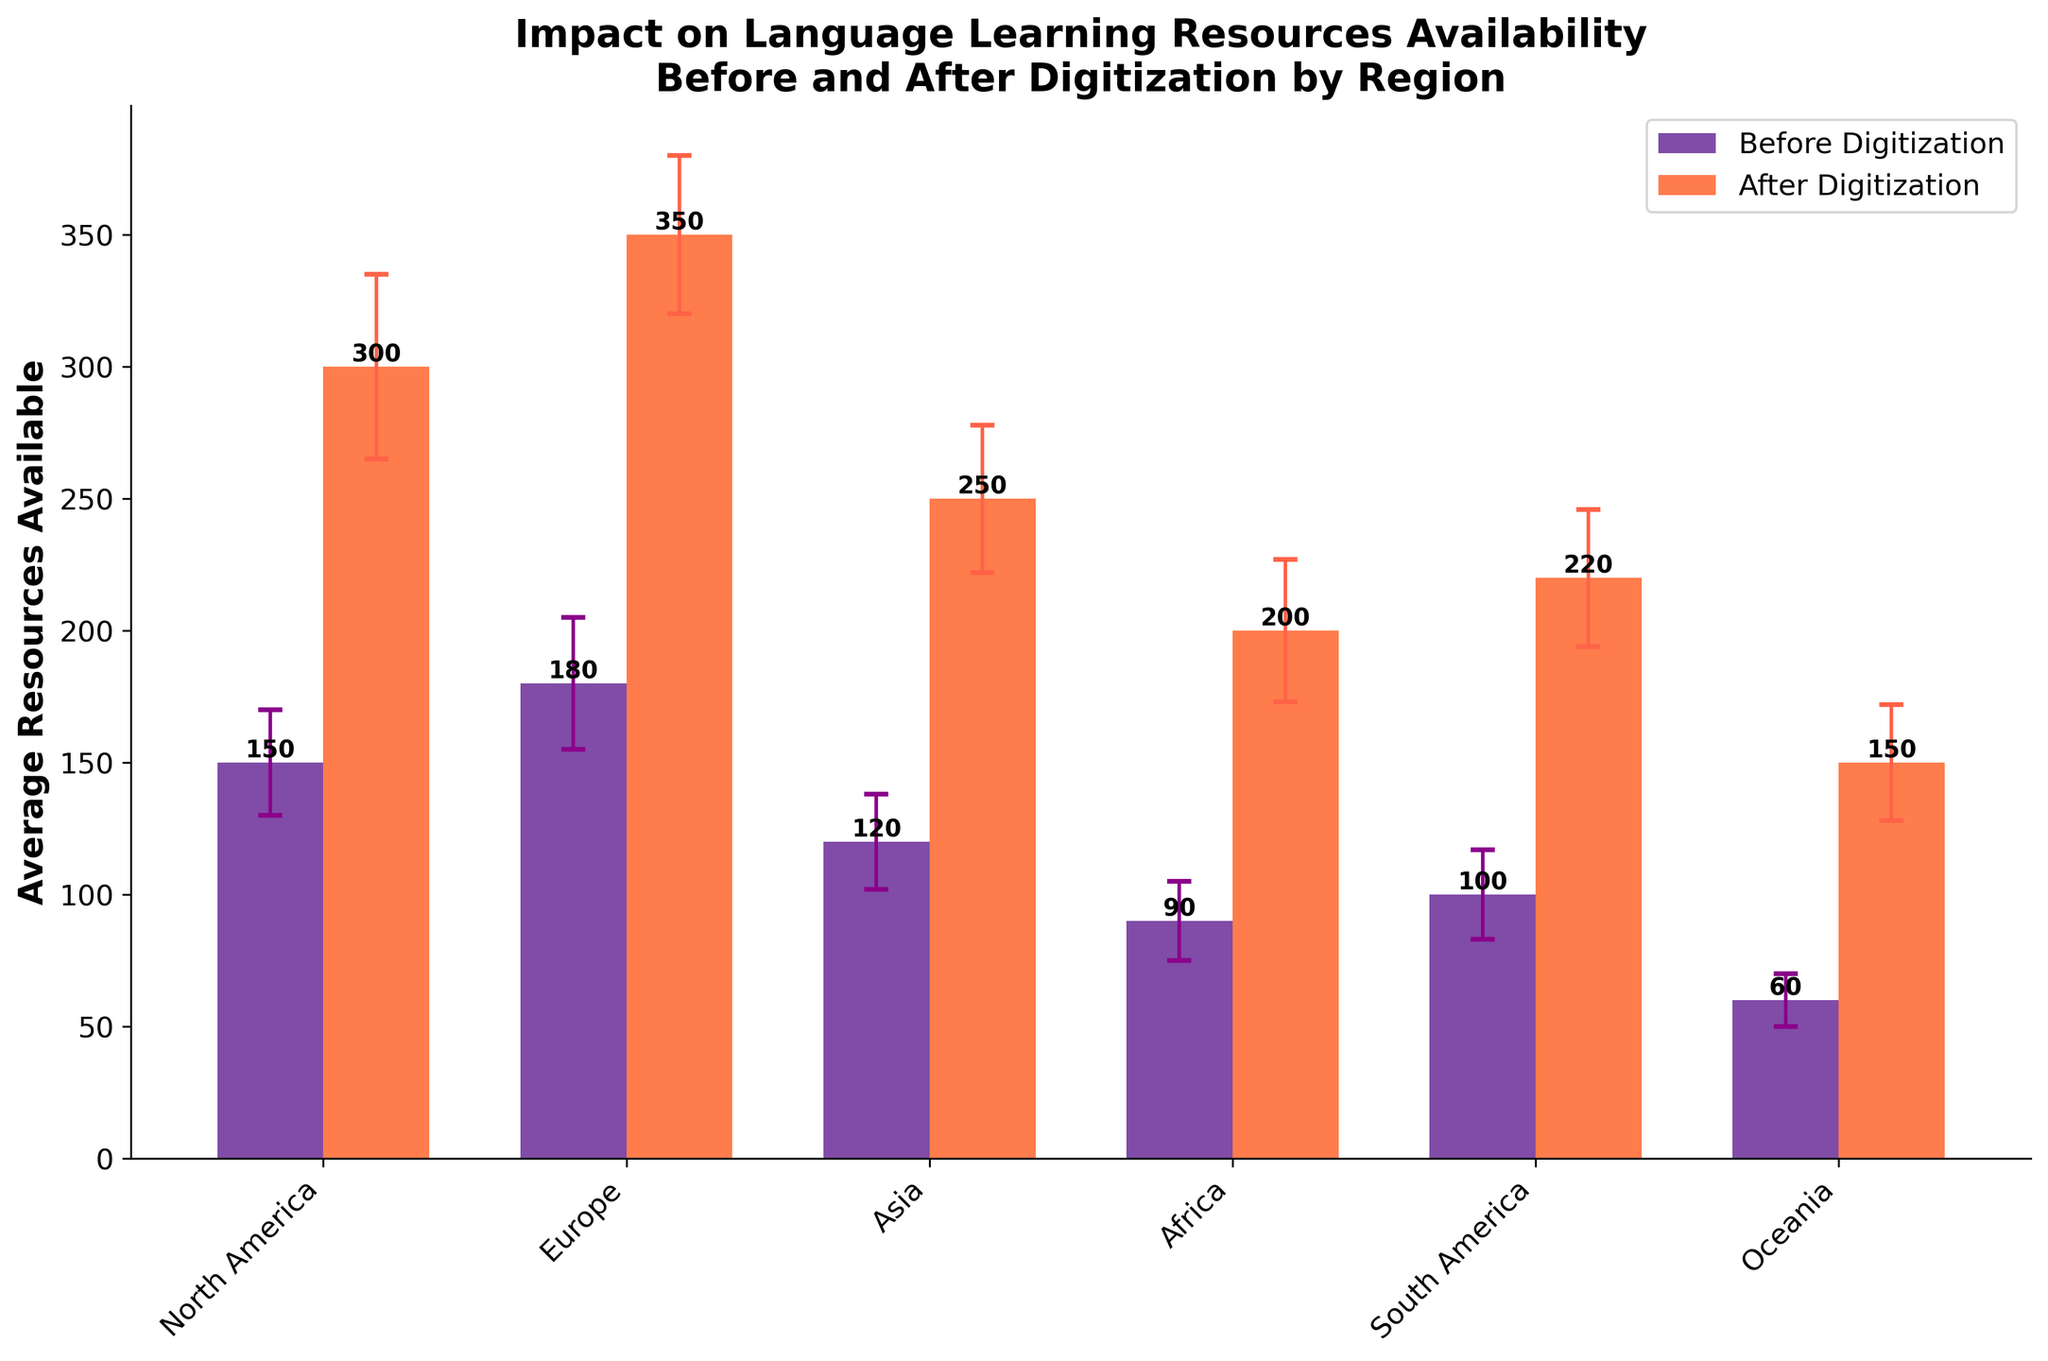What is the title of the bar chart? The title is displayed at the top of the figure and concisely summarizes its content. Therefore, the title of the bar chart is "Impact on Language Learning Resources Availability Before and After Digitization by Region."
Answer: Impact on Language Learning Resources Availability Before and After Digitization by Region What is the average number of language learning resources available in Oceania before digitization? The average number of resources available is represented by the height of the bar corresponding to Oceania under the "Before Digitization" category. This value is 60.
Answer: 60 Which region experienced the highest increase in average resources available after digitization? To determine the highest increase, we need to compare the difference in the number of resources before and after digitization for each region. By examining the bars, Europe experienced the highest increase: 350 (after) - 180 (before) = 170 resources.
Answer: Europe What is the error margin for the average resources available in North America after digitization? The error bars represent the standard deviation. For North America after digitization, the standard deviation is 35. This is shown by the height of the error bar extending above and below the bar for North America in the "After Digitization" category.
Answer: 35 How does the average number of resources available in Africa compare before and after digitization? Comparing the heights of the bars for Africa, we see that before digitization, the average number was 90, and after digitization, it was 200. Thus, there is an increase from 90 to 200.
Answer: Increase from 90 to 200 Which two regions have the smallest difference in the average number of resources before and after digitization? By calculating the difference for each region, we can identify the smallest differences:
- North America: 300 - 150 = 150
- Europe: 350 - 180 = 170
- Asia: 250 - 120 = 130
- Africa: 200 - 90 = 110
- South America: 220 - 100 = 120
- Oceania: 150 - 60 = 90
Hence, the two regions with the smallest differences are Africa (110) and Oceania (90).
Answer: Africa and Oceania What color represents the average resources available before digitization? The average resources available before digitization are represented by deep purple or indigo colored bars in the chart.
Answer: Indigo Are the error margins for the average resources available larger before or after digitization in South America? To answer this, we need to compare the error margins (standard deviations) for “Before Digitization” and “After Digitization” in South America. The standard deviation before digitization is 17 and after digitization is 26. Thus, the error margin is larger after digitization.
Answer: After digitization What is the approximate increase in average resources for Asia after digitization? By examining the height of the bars for Asia, the average resources available before digitization are 120, and after digitization, it is 250. The approximate increase can be calculated as 250 - 120 = 130.
Answer: 130 